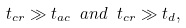Convert formula to latex. <formula><loc_0><loc_0><loc_500><loc_500>t _ { c r } \gg t _ { a c } \ a n d \ t _ { c r } \gg t _ { d } ,</formula> 